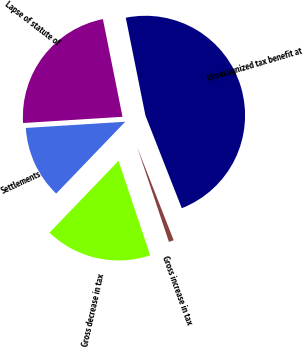<chart> <loc_0><loc_0><loc_500><loc_500><pie_chart><fcel>Unrecognized tax benefit at<fcel>Gross increase in tax<fcel>Gross decrease in tax<fcel>Settlements<fcel>Lapse of statute of<nl><fcel>47.21%<fcel>0.8%<fcel>17.33%<fcel>11.82%<fcel>22.84%<nl></chart> 